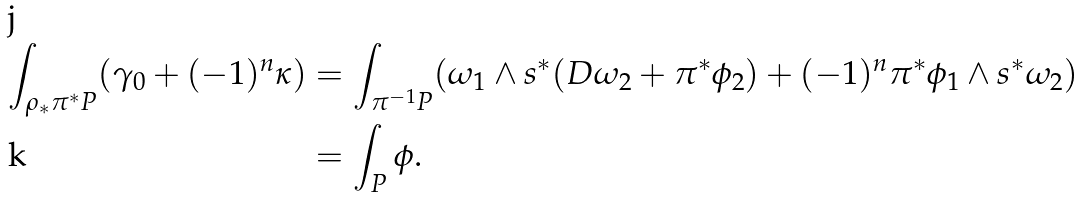Convert formula to latex. <formula><loc_0><loc_0><loc_500><loc_500>\int _ { \rho _ { * } \pi ^ { * } P } ( \gamma _ { 0 } + ( - 1 ) ^ { n } \kappa ) & = \int _ { \pi ^ { - 1 } P } ( \omega _ { 1 } \wedge s ^ { * } ( D \omega _ { 2 } + \pi ^ { * } \phi _ { 2 } ) + ( - 1 ) ^ { n } \pi ^ { * } \phi _ { 1 } \wedge s ^ { * } \omega _ { 2 } ) \\ & = \int _ { P } \phi .</formula> 